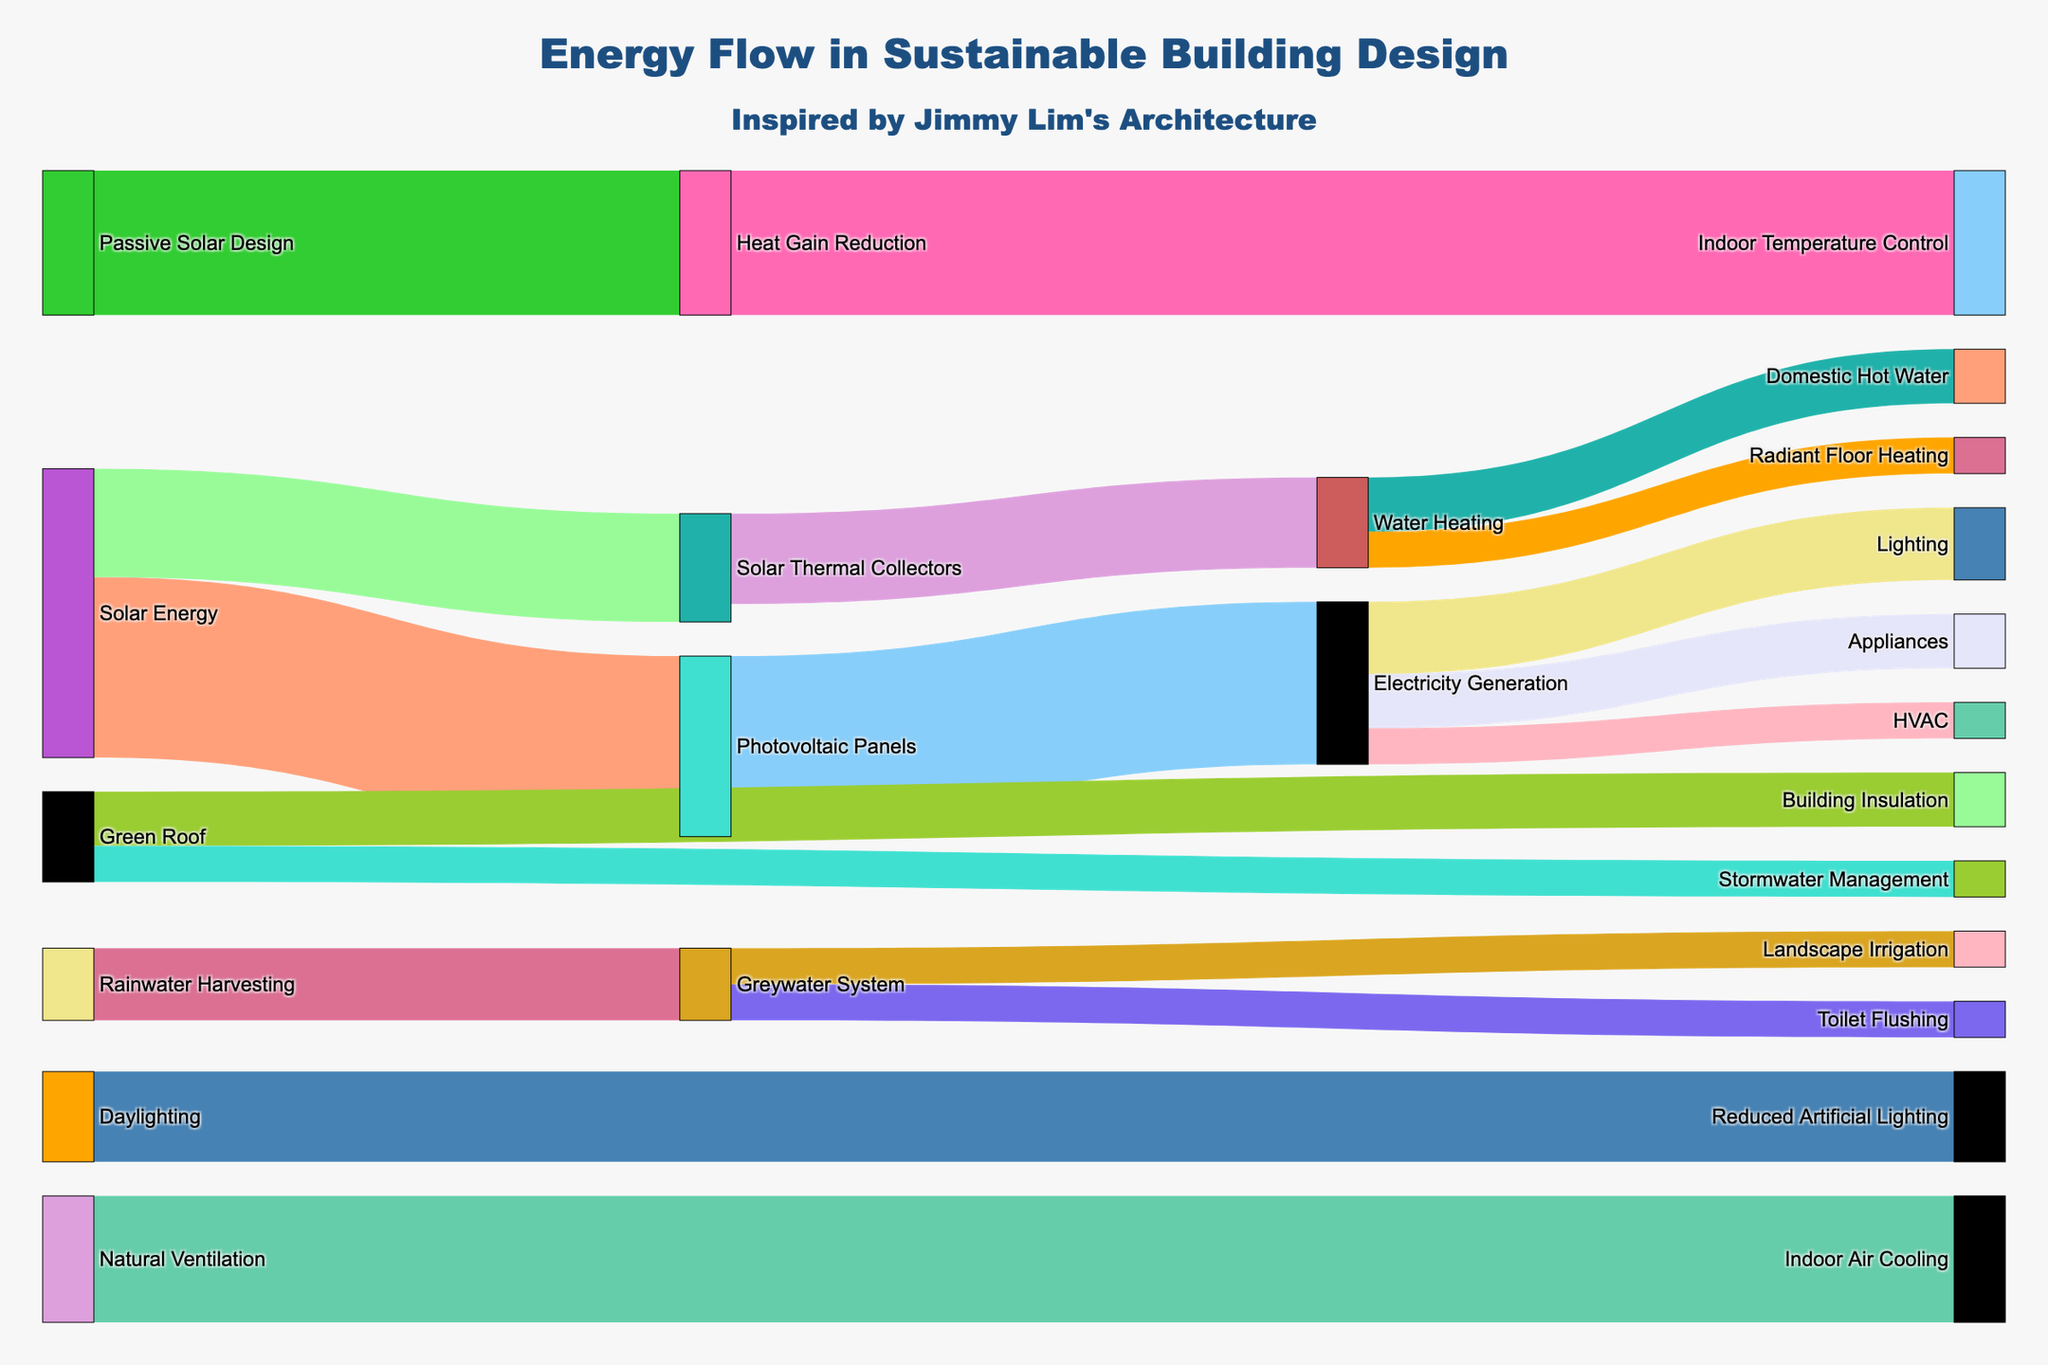How many energy sources are there in the building design? The diagram displays the various sources flowing into different targets. By listing the distinct sources from the data provided, we count Solar Energy, Photovoltaic Panels, Solar Thermal Collectors, Electricity Generation, Water Heating, Natural Ventilation, Rainwater Harvesting, Passive Solar Design, Daylighting, and Green Roof.
Answer: 10 What is the largest flow of energy from a source to a target? By examining the values of each connection, we identify that the largest flow is from Solar Energy to Photovoltaic Panels, with a value of 50.
Answer: Solar Energy to Photovoltaic Panels, 50 Which elements receive energy from 'Electricity Generation'? The diagram shows the flow from Electricity Generation splitting into Lighting, Appliances, and HVAC.
Answer: Lighting, Appliances, HVAC What is the combined value of energy flow from 'Water Heating'? 'Water Heating' flows into Domestic Hot Water and Radiant Floor Heating with values of 15 and 10, respectively. Adding these gives 15 + 10 = 25.
Answer: 25 Which source contributes to 'Reduced Artificial Lighting'? By following the flows, we observe that Daylighting leads to Reduced Artificial Lighting.
Answer: Daylighting What is the total value of energy sourced from 'Solar Energy'? Summing up the values from Solar Energy to Photovoltaic Panels (50) and Solar Thermal Collectors (30) results in 50 + 30 = 80.
Answer: 80 How does 'Green Roof' contribute to the building design? The Green Roof is connected to Building Insulation and Stormwater Management with values of 15 and 10, respectively.
Answer: Building Insulation, Stormwater Management Between 'Indoor Air Cooling' from Natural Ventilation and 'Indoor Temperature Control' from Heat Gain Reduction, which is greater? 'Indoor Air Cooling' has a value of 35, while 'Indoor Temperature Control' has a value of 40. Comparing these, 40 is greater than 35.
Answer: Indoor Temperature Control What is the flow contributing to 'Domestic Hot Water' and how significant is it? Reviewing 'Water Heating' which leads to Domestic Hot Water, we find a value of 15. Considering the overall values, it shows a moderate contribution.
Answer: 15, moderate How does 'Rainwater Harvesting' influence water management? 'Rainwater Harvesting' connects to the Greywater System with a value of 20, which then flows into Toilet Flushing and Landscape Irrigation with values of 10 each. This shows its role in recycling water resources efficiently.
Answer: Toilet Flushing, Landscape Irrigation 